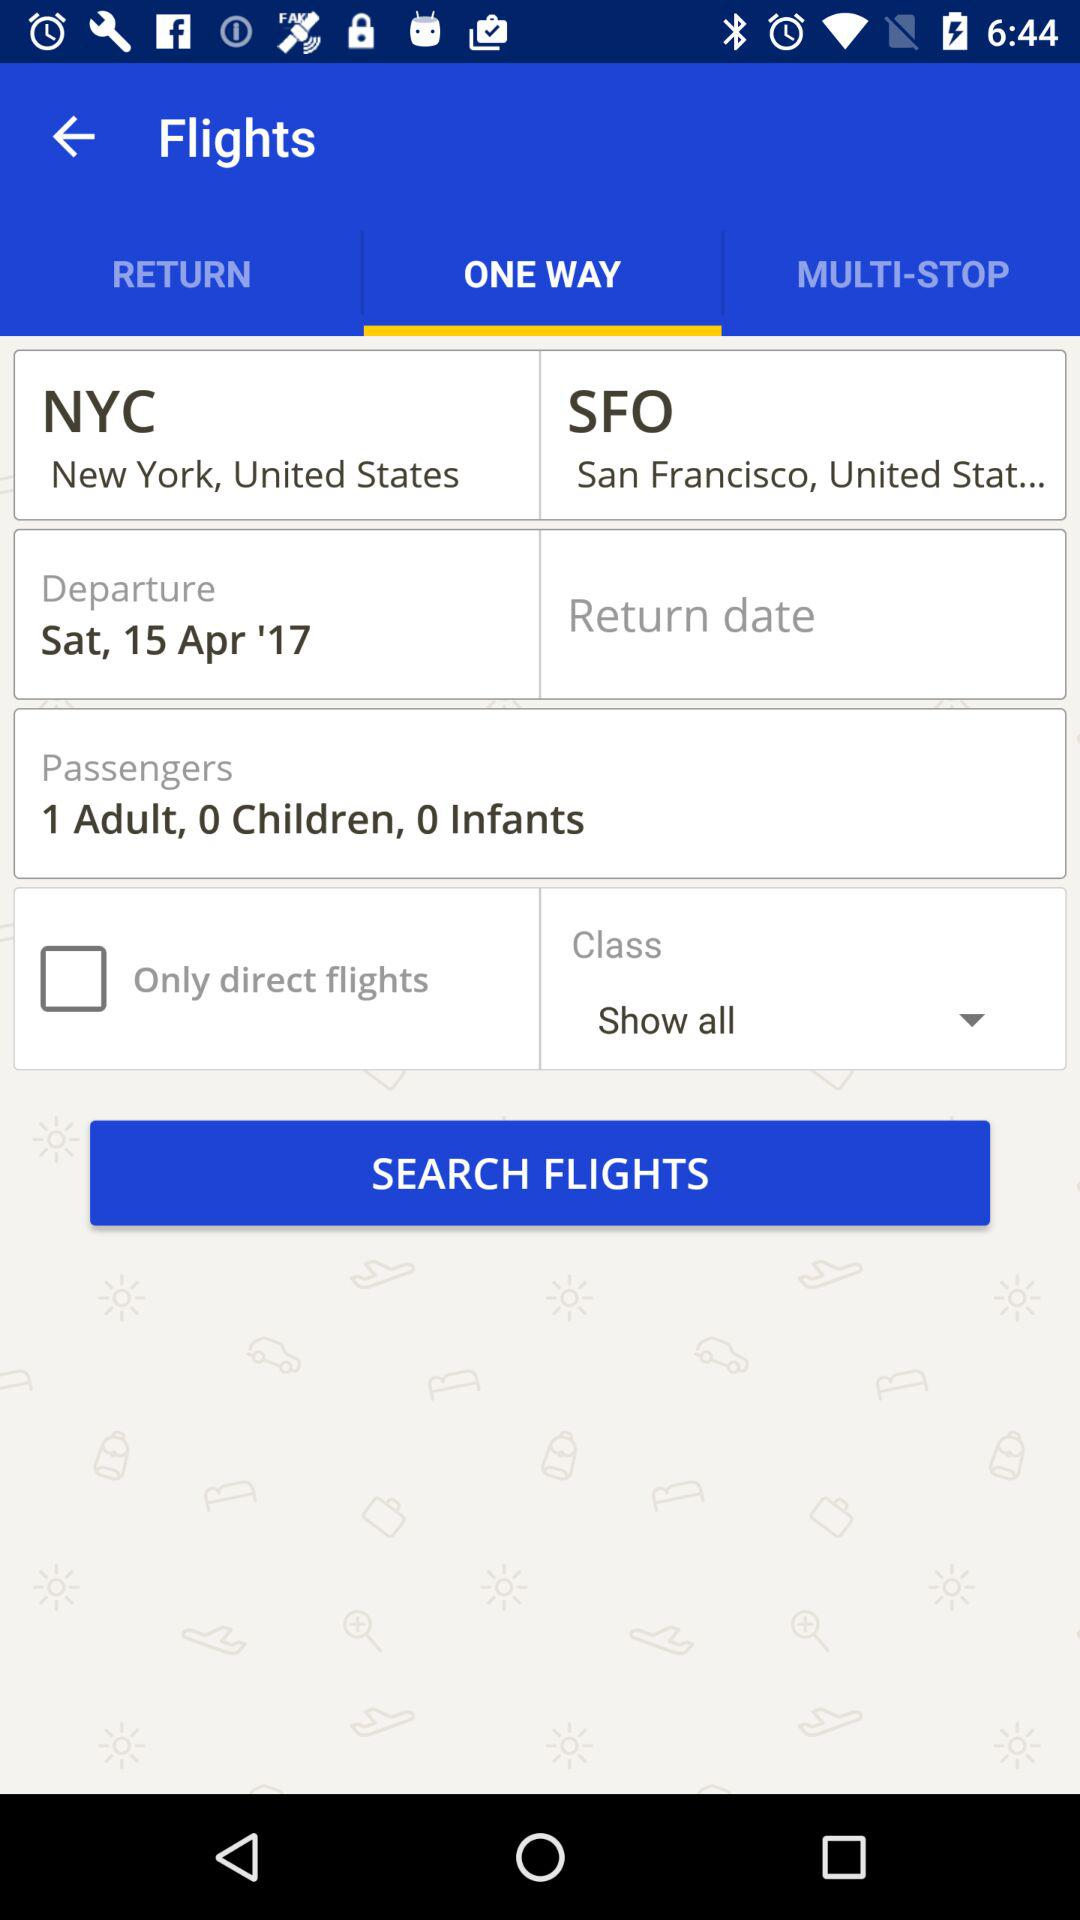From where to where the flights have been searched? The flights have been searched from New York, United States to San Francisco, United States. 